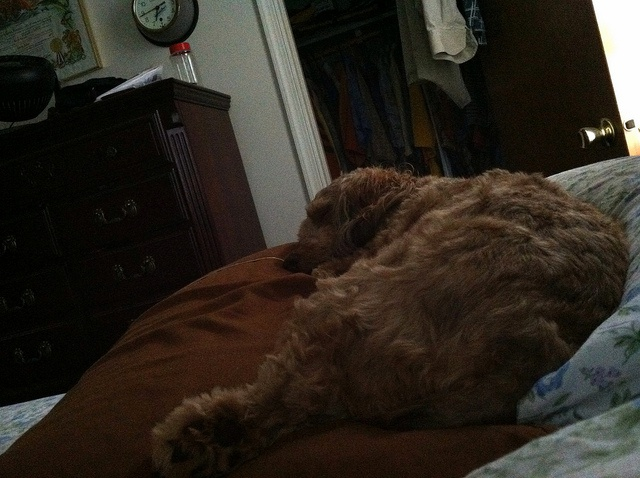Describe the objects in this image and their specific colors. I can see dog in black, maroon, and gray tones, bed in black, gray, maroon, and purple tones, clock in black, gray, and darkgreen tones, and bottle in black, gray, maroon, and darkgray tones in this image. 